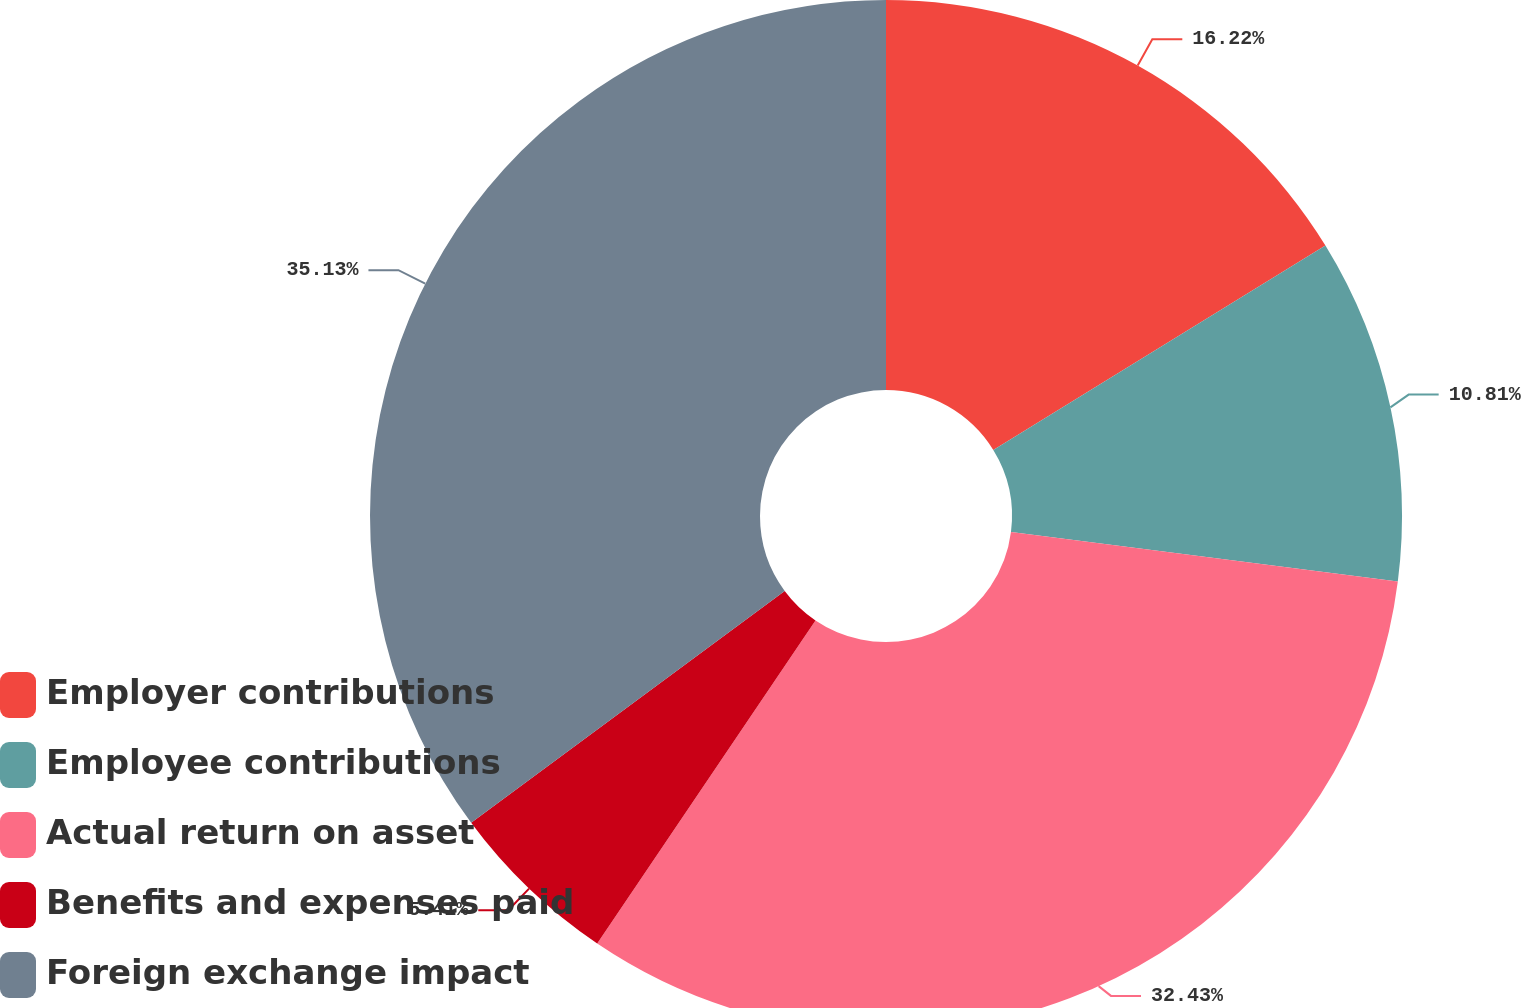Convert chart. <chart><loc_0><loc_0><loc_500><loc_500><pie_chart><fcel>Employer contributions<fcel>Employee contributions<fcel>Actual return on asset<fcel>Benefits and expenses paid<fcel>Foreign exchange impact<nl><fcel>16.22%<fcel>10.81%<fcel>32.43%<fcel>5.41%<fcel>35.14%<nl></chart> 